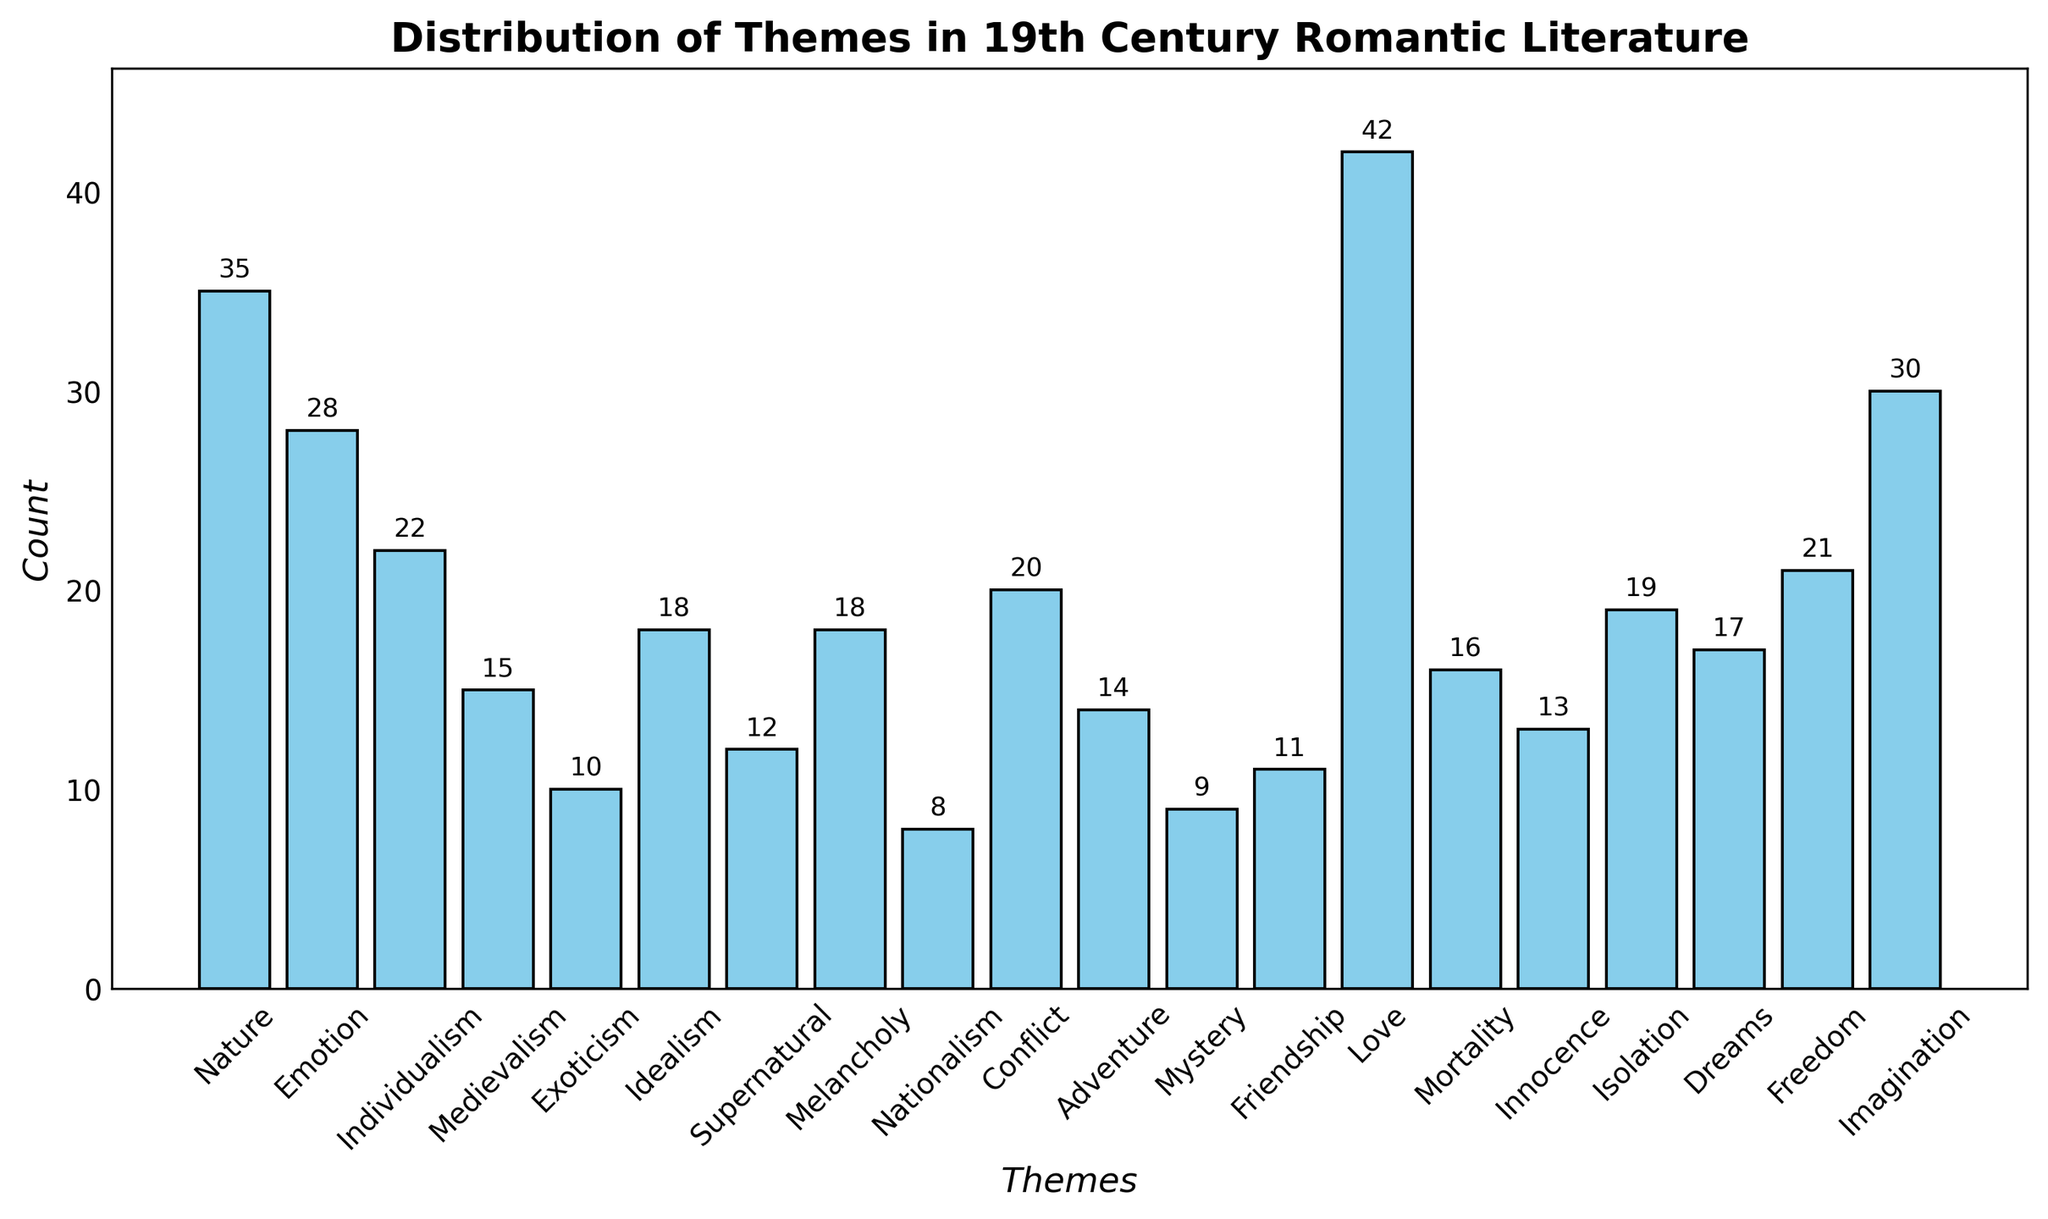What theme has the highest count? Looking at the height of all the bars, the tallest bar corresponds to the theme "Love". The title and y-axis label also provide context that the count is the measure being examined, thus "Love" has the highest count.
Answer: Love What is the combined count of the "Nature" and "Emotion" themes? Identify the count for "Nature" which is 35, and for "Emotion" which is 28. Add these two counts together: 35 + 28 = 63.
Answer: 63 Which theme has a count closest to 20? Looking at the height of the bars around the value 20 on the y-axis, the theme "Conflict" has a count that exactly matches 20.
Answer: Conflict How does the count of "Imagination" compare to "Individualism"? The bar for "Imagination" is higher than the bar for "Individualism", denoting that "Imagination" has a higher count. Specifically, "Imagination" has a count of 30, while "Individualism" has a count of 22. Therefore, "Imagination" > "Individualism" in terms of count.
Answer: Imagination > Individualism Which theme has a count twice as much as "Exoticism"? Find the count for "Exoticism" which is 10. Double this count to get 10 * 2 = 20. Check for the theme with a count of 20. The theme "Conflict" has a count of 20.
Answer: Conflict What is the difference in count between "Love" and "Freedom"? The count for "Love" is 42, and for "Freedom" is 21. Subtract the count of "Freedom" from "Love": 42 - 21 = 21.
Answer: 21 Which theme has a higher count, "Mystery" or "Friendship"? Compare the heights of the bars for "Mystery" and "Friendship". "Friendship" has a count of 11, and "Mystery" has a count of 9. Therefore, "Friendship" has a higher count than "Mystery".
Answer: Friendship Which three themes have the lowest counts? Identify the shortest bars. The themes "Nationalism" (8), "Mystery" (9), and "Exoticism" (10) have the lowest counts.
Answer: Nationalism, Mystery, Exoticism What themes have counts greater than 25 but less than 35? Scan the bars with heights within the range of 25 to 35. The themes "Imagination" (30) and "Nature" (35) fall into this category. Hence, only "Imagination" since it’s less than 35 but greater than 25.
Answer: Imagination What is the average count of the themes "Adventure", "Dreams", and "Innocence"? Identify the counts for "Adventure" (14), "Dreams" (17), and "Innocence" (13). Calculate the average: (14 + 17 + 13) / 3 = 44 / 3 ≈ 14.67.
Answer: 14.67 